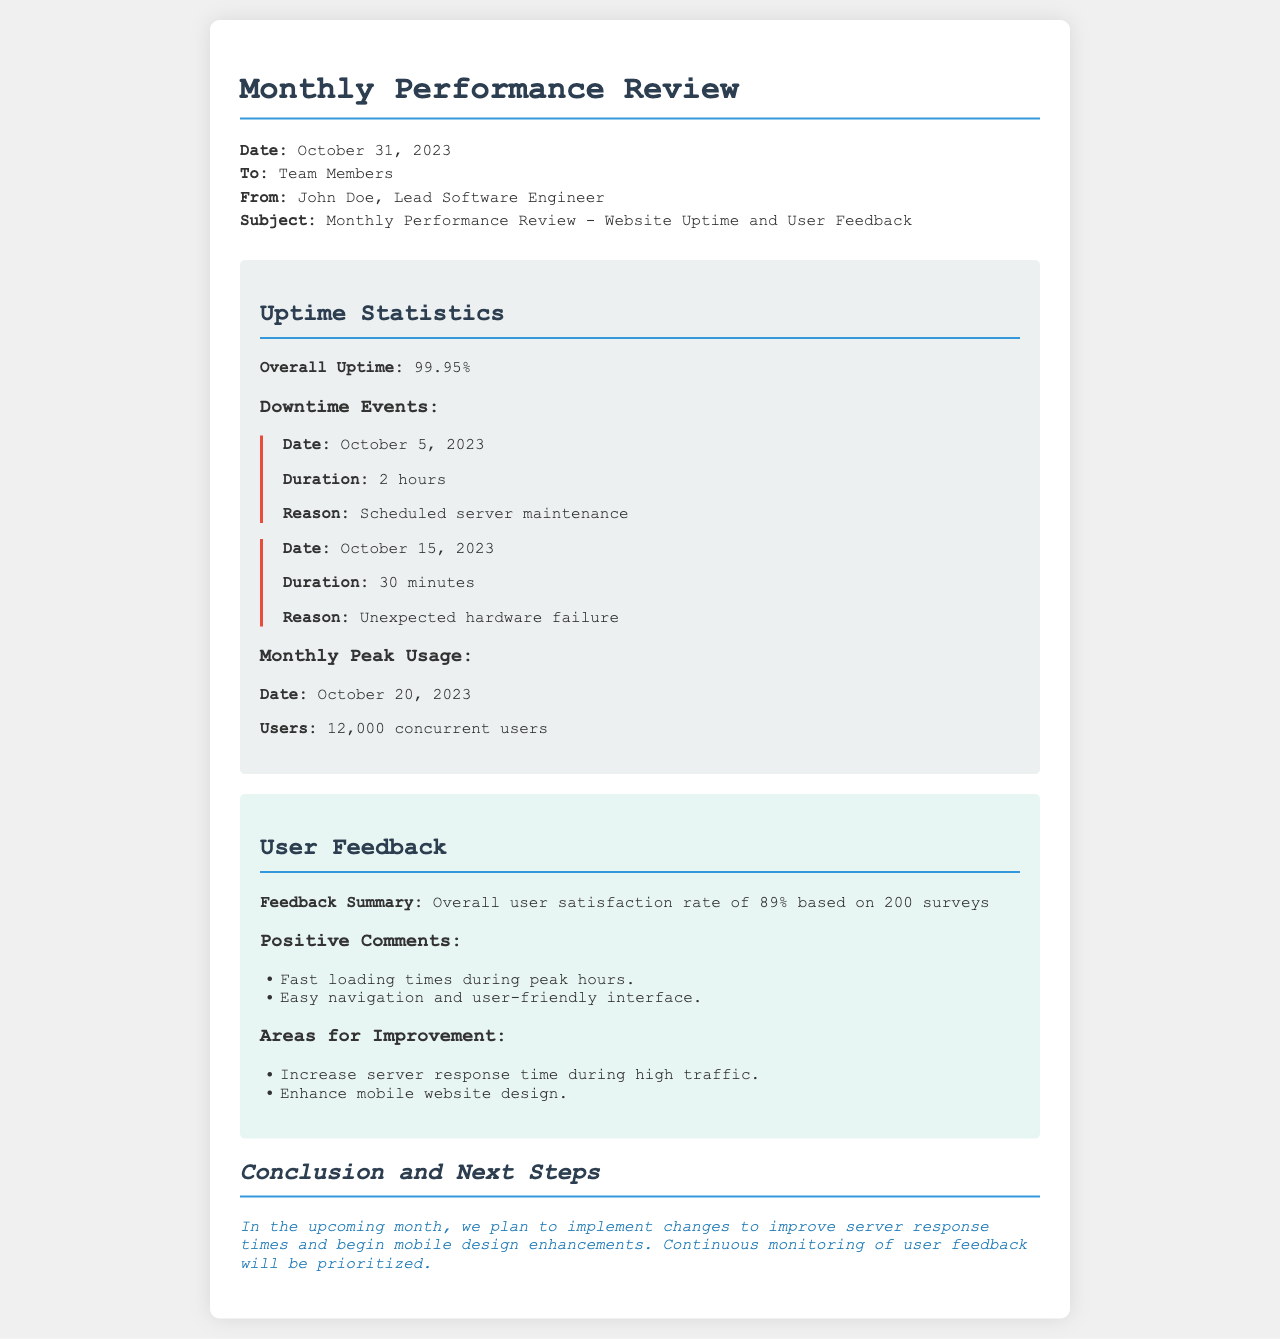what is the overall uptime percentage? The overall uptime percentage is stated in the uptime statistics section of the document.
Answer: 99.95% how many downtime events are listed? The document provides a count of downtime events mentioned under the downtime events section.
Answer: 2 what was the reason for the downtime on October 15, 2023? The reason for the downtime is found in the description of the specific event on that date.
Answer: Unexpected hardware failure how many surveys were collected for user feedback? The number of surveys is provided in the user feedback summary section of the document.
Answer: 200 what is the user satisfaction rate? The user satisfaction rate is included in the feedback summary section.
Answer: 89% what was the peak usage date in October 2023? The document specifies the date of peak usage in the uptime statistics section.
Answer: October 20, 2023 what areas for improvement were highlighted? The information about areas for improvement is listed in a specific section of the user feedback.
Answer: Increase server response time during high traffic, Enhance mobile website design who is the author of the document? The author’s name is mentioned in the header of the document, specifically labeled as "From:".
Answer: John Doe what are the next steps mentioned in the conclusion? The next steps are detailed in the conclusion and specify actions to be taken in the upcoming month.
Answer: Implement changes to improve server response times and begin mobile design enhancements 